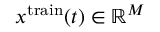Convert formula to latex. <formula><loc_0><loc_0><loc_500><loc_500>x ^ { t r a i n } ( t ) \in \mathbb { R } ^ { M }</formula> 